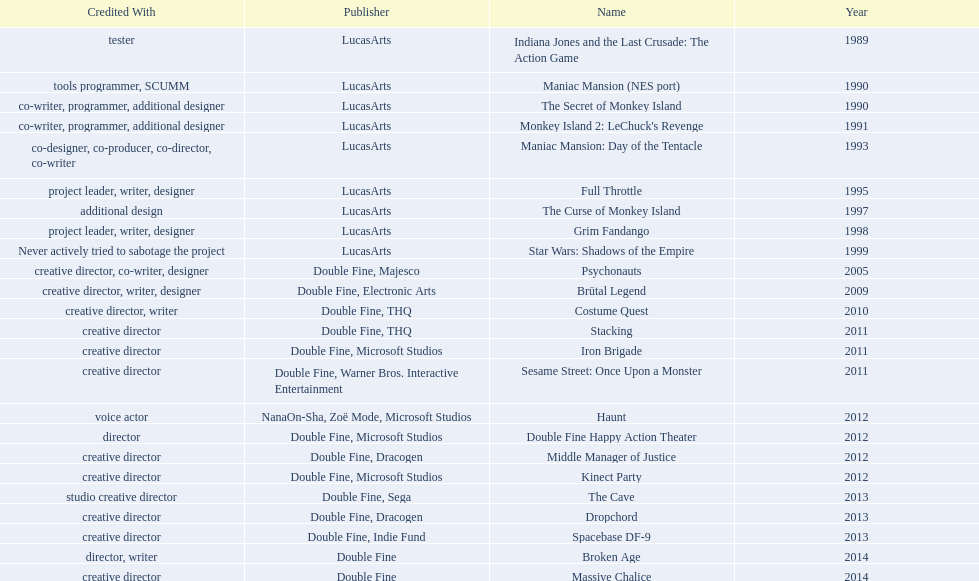Which productions did tim schafer work on that were published in part by double fine? Psychonauts, Brütal Legend, Costume Quest, Stacking, Iron Brigade, Sesame Street: Once Upon a Monster, Double Fine Happy Action Theater, Middle Manager of Justice, Kinect Party, The Cave, Dropchord, Spacebase DF-9, Broken Age, Massive Chalice. Which of these was he a creative director? Psychonauts, Brütal Legend, Costume Quest, Stacking, Iron Brigade, Sesame Street: Once Upon a Monster, Middle Manager of Justice, Kinect Party, The Cave, Dropchord, Spacebase DF-9, Massive Chalice. Which of those were in 2011? Stacking, Iron Brigade, Sesame Street: Once Upon a Monster. What was the only one of these to be co published by warner brothers? Sesame Street: Once Upon a Monster. 